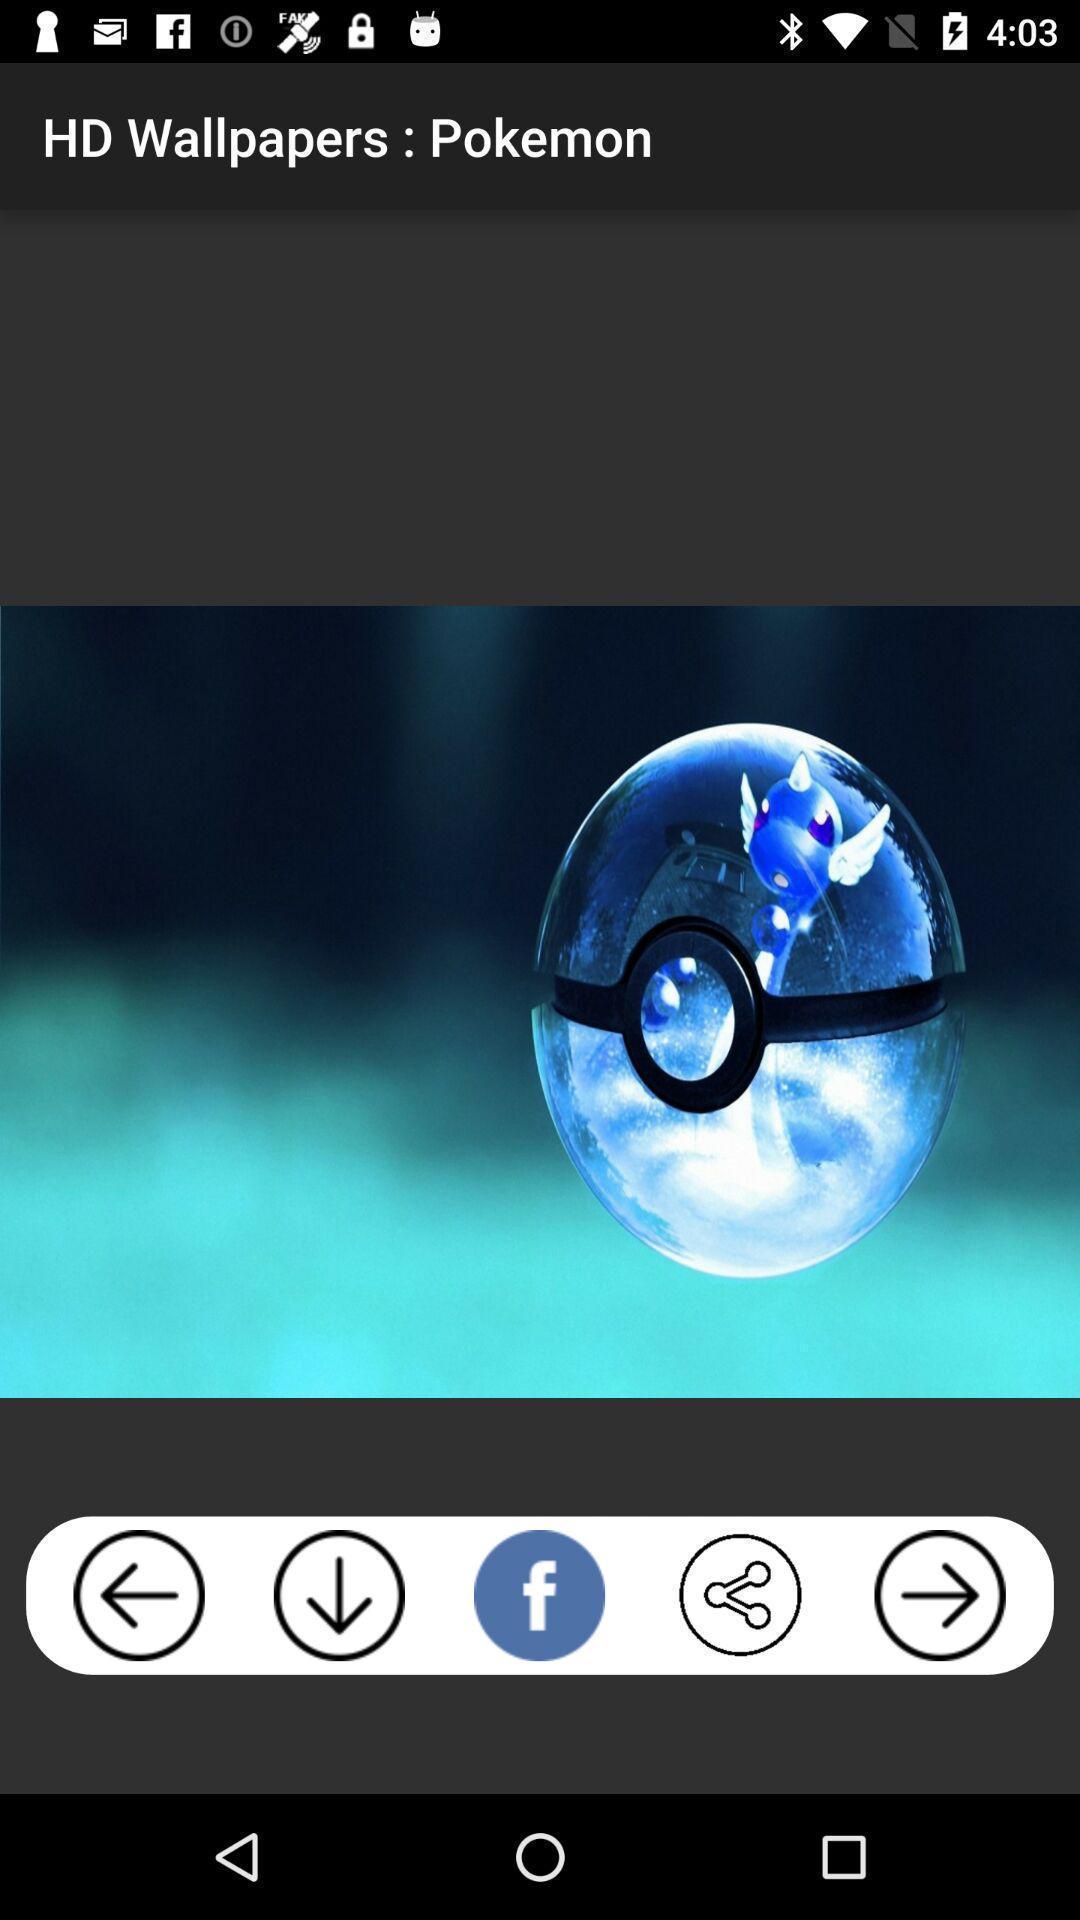Tell me about the visual elements in this screen capture. Screen showing wallpaper. 